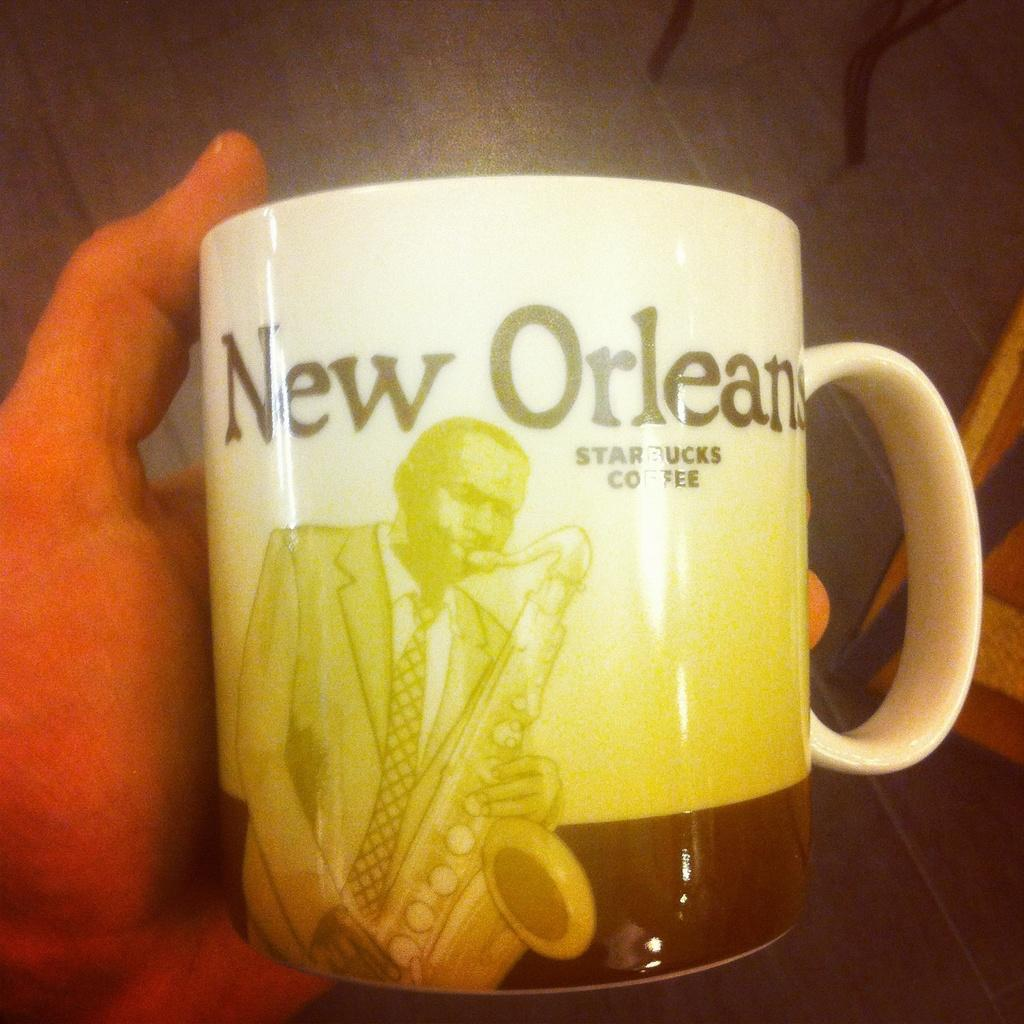What is the person's hand holding in the image? The person's hand is holding a mug in the image. Where is the hand holding the mug located in the image? The hand holding the mug is in the foreground of the image. What is visible at the bottom of the image? There is a table at the bottom of the image. How many pies are on the table in the image? There are no pies visible on the table in the image. 